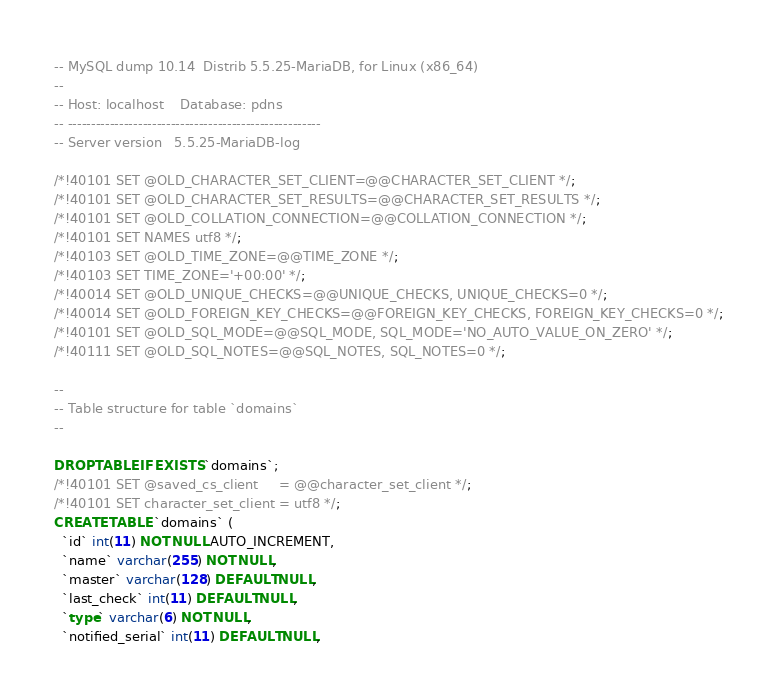Convert code to text. <code><loc_0><loc_0><loc_500><loc_500><_SQL_>-- MySQL dump 10.14  Distrib 5.5.25-MariaDB, for Linux (x86_64)
--
-- Host: localhost    Database: pdns
-- ------------------------------------------------------
-- Server version	5.5.25-MariaDB-log

/*!40101 SET @OLD_CHARACTER_SET_CLIENT=@@CHARACTER_SET_CLIENT */;
/*!40101 SET @OLD_CHARACTER_SET_RESULTS=@@CHARACTER_SET_RESULTS */;
/*!40101 SET @OLD_COLLATION_CONNECTION=@@COLLATION_CONNECTION */;
/*!40101 SET NAMES utf8 */;
/*!40103 SET @OLD_TIME_ZONE=@@TIME_ZONE */;
/*!40103 SET TIME_ZONE='+00:00' */;
/*!40014 SET @OLD_UNIQUE_CHECKS=@@UNIQUE_CHECKS, UNIQUE_CHECKS=0 */;
/*!40014 SET @OLD_FOREIGN_KEY_CHECKS=@@FOREIGN_KEY_CHECKS, FOREIGN_KEY_CHECKS=0 */;
/*!40101 SET @OLD_SQL_MODE=@@SQL_MODE, SQL_MODE='NO_AUTO_VALUE_ON_ZERO' */;
/*!40111 SET @OLD_SQL_NOTES=@@SQL_NOTES, SQL_NOTES=0 */;

--
-- Table structure for table `domains`
--

DROP TABLE IF EXISTS `domains`;
/*!40101 SET @saved_cs_client     = @@character_set_client */;
/*!40101 SET character_set_client = utf8 */;
CREATE TABLE `domains` (
  `id` int(11) NOT NULL AUTO_INCREMENT,
  `name` varchar(255) NOT NULL,
  `master` varchar(128) DEFAULT NULL,
  `last_check` int(11) DEFAULT NULL,
  `type` varchar(6) NOT NULL,
  `notified_serial` int(11) DEFAULT NULL,</code> 